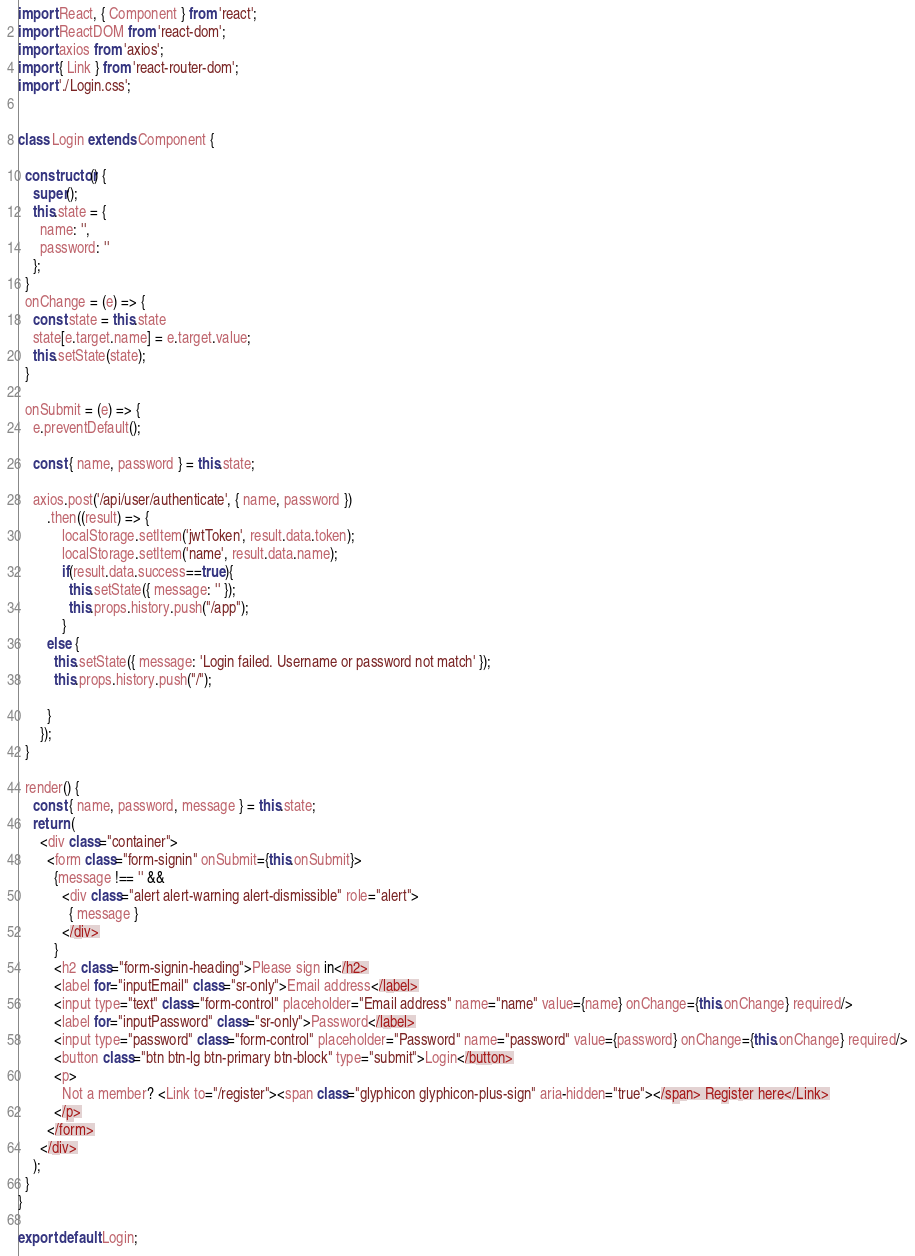Convert code to text. <code><loc_0><loc_0><loc_500><loc_500><_JavaScript_>import React, { Component } from 'react';
import ReactDOM from 'react-dom';
import axios from 'axios';
import { Link } from 'react-router-dom';
import './Login.css';


class Login extends Component {

  constructor() {
    super();
    this.state = {
      name: '',
      password: ''
    };
  }
  onChange = (e) => {
    const state = this.state
    state[e.target.name] = e.target.value;
    this.setState(state);
  }

  onSubmit = (e) => {
    e.preventDefault();

    const { name, password } = this.state;

    axios.post('/api/user/authenticate', { name, password })
        .then((result) => {
            localStorage.setItem('jwtToken', result.data.token);
            localStorage.setItem('name', result.data.name);
            if(result.data.success==true){
              this.setState({ message: '' });
              this.props.history.push("/app");
            }
        else {
          this.setState({ message: 'Login failed. Username or password not match' });
          this.props.history.push("/");

        }
      });
  }

  render() {
    const { name, password, message } = this.state;
    return (
      <div class="container">
        <form class="form-signin" onSubmit={this.onSubmit}>
          {message !== '' &&
            <div class="alert alert-warning alert-dismissible" role="alert">
              { message }
            </div>
          }
          <h2 class="form-signin-heading">Please sign in</h2>
          <label for="inputEmail" class="sr-only">Email address</label>
          <input type="text" class="form-control" placeholder="Email address" name="name" value={name} onChange={this.onChange} required/>
          <label for="inputPassword" class="sr-only">Password</label>
          <input type="password" class="form-control" placeholder="Password" name="password" value={password} onChange={this.onChange} required/>
          <button class="btn btn-lg btn-primary btn-block" type="submit">Login</button>
          <p>
            Not a member? <Link to="/register"><span class="glyphicon glyphicon-plus-sign" aria-hidden="true"></span> Register here</Link>
          </p>
        </form>
      </div>
    );
  }
}

export default Login;
</code> 